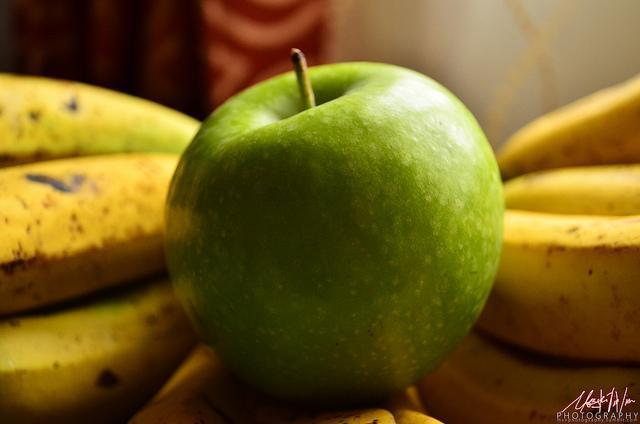How many bananas are in the photo?
Give a very brief answer. 6. How many fruit is in the picture?
Give a very brief answer. 2. How many bananas can be seen?
Give a very brief answer. 5. 